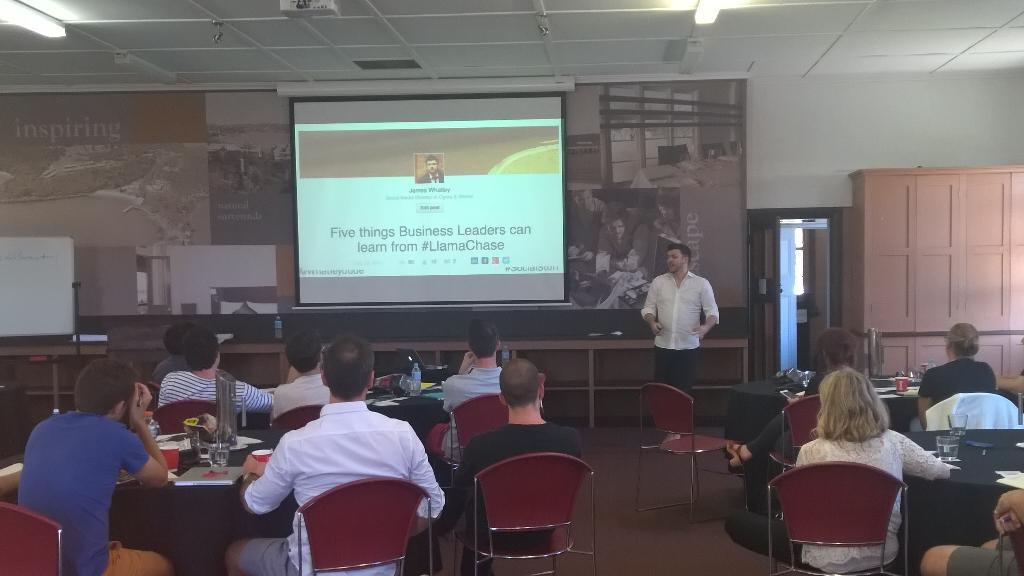What are the people in the image doing? There is a group of people sitting in the image. Is there anyone standing in the image? Yes, there is a person standing in the image. What is the purpose of the projector screen in the image? The projector screen is likely used for displaying visuals during a presentation or event. Where is the projector located in the image? The projector is on the ceiling in the image. Can you describe the spark coming from the projector in the image? There is no spark coming from the projector in the image. How does the earthquake affect the people sitting in the image? There is no earthquake present in the image; the people are sitting calmly. 